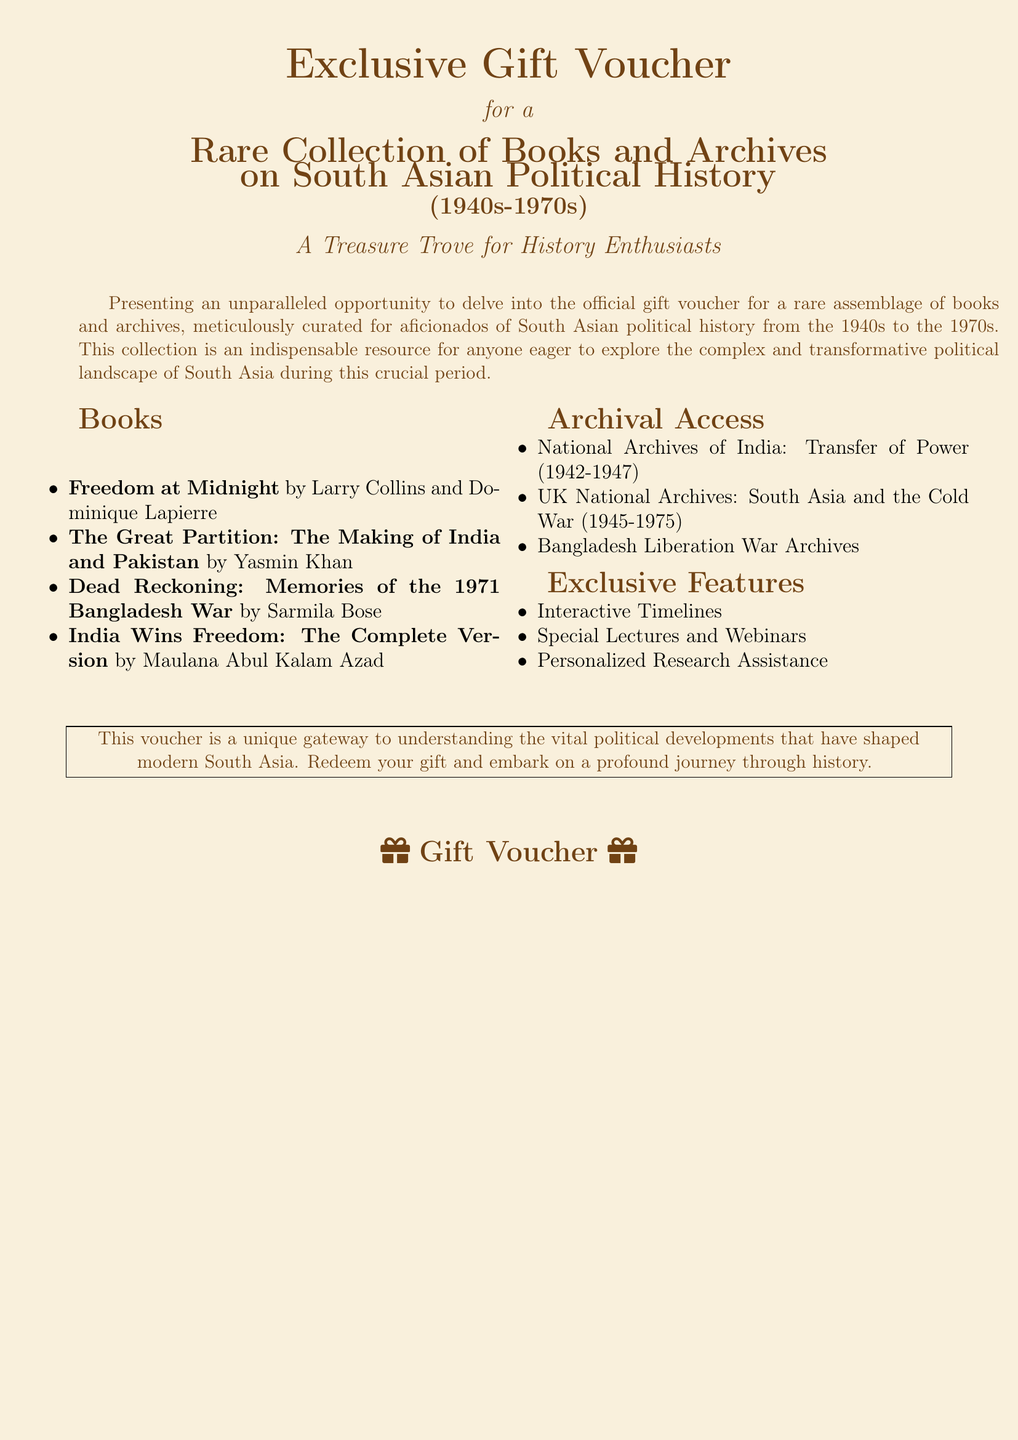What is the title of the voucher? The title of the voucher is stated at the top of the document, emphasizing that it's an exclusive gift voucher.
Answer: Exclusive Gift Voucher Who authored the book "Freedom at Midnight"? This question seeks the name of the authors mentioned for this specific book in the collection.
Answer: Larry Collins and Dominique Lapierre What is the time period covered by the rare collection? The document specifies the time period for the collection, which is crucial for understanding its historical context.
Answer: 1940s-1970s What special feature is included for personalized support? The document lists interactive features, and this question focuses on what kind of tailored assistance is highlighted.
Answer: Personalized Research Assistance How many books are listed in the voucher? This question asks for a quick count of the books mentioned to grasp the collection’s scope.
Answer: 4 What type of archives can be accessed through this voucher? The document lists different archival accesses available, so the question targets the type or kinds mentioned.
Answer: National Archives of India What is the purpose of the voucher as stated in the document? This question looks for the intended use or objective of the voucher as described in the text.
Answer: Understanding political developments Which significant historical event is referenced in the book by Sarmila Bose? The document provides clues about the themes and titles of the books; this question targets a specific historical event.
Answer: Bangladesh War 